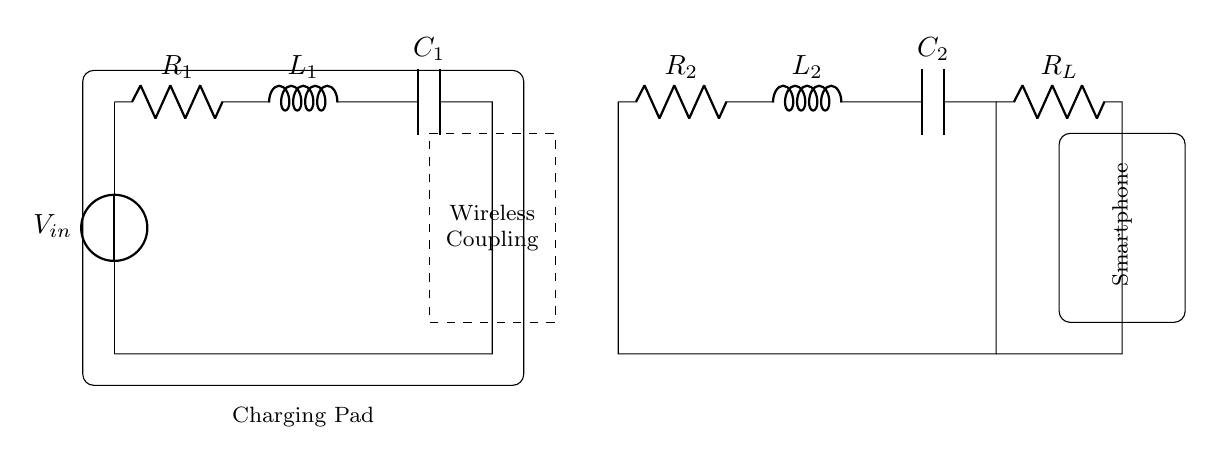What is the total number of energy storage components in this circuit? In the circuit, there are two energy storage components: one inductor and one capacitor each from the transmitter and receiver sides. This makes a total of four energy storage components.
Answer: four What type of circuit is this? This is a resonant RLC circuit, as indicated by the presence of resistors, inductors, and capacitors. The coupling between the transmitter and receiver suggests it is designed for a resonant operation, typically used in wireless power transfer.
Answer: resonant RLC What is the role of the wireless coupling component? The wireless coupling component allows energy transfer between the transmitter and receiver without physical connections. This is crucial for applications like smartphone charging pads, enabling distance charging through electromagnetic induction.
Answer: energy transfer What do the values R1, L1, C1 represent in the transmitter circuit? R1 is the resistance in the transmitter circuit, L1 is the inductance, and C1 is the capacitance. Together, they form the resonant circuit that helps in tuning the circuit to the desired frequency for efficient wireless power transfer.
Answer: resistance, inductance, capacitance What is the load resistor in the circuit? The load resistor, labeled R_L, is the component connected to the receiver circuit that represents the resistance of the smartphone being charged. This resistor essentially consumes the power transferred wirelessly for charging the device.
Answer: R_L 